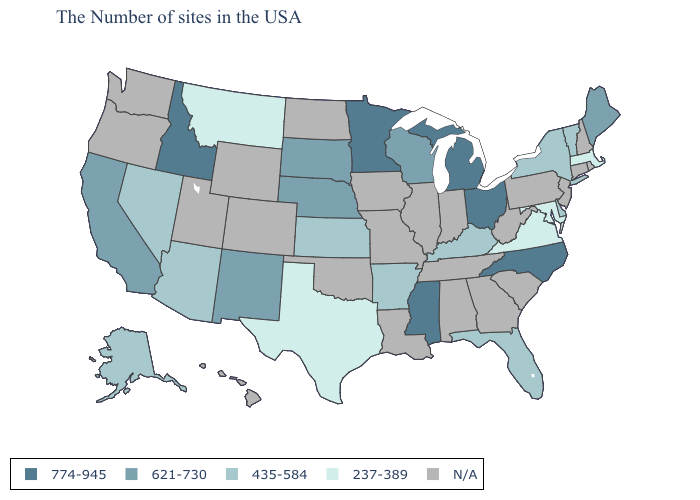What is the highest value in the USA?
Give a very brief answer. 774-945. What is the lowest value in the USA?
Be succinct. 237-389. What is the highest value in states that border Montana?
Short answer required. 774-945. What is the value of Wyoming?
Concise answer only. N/A. Name the states that have a value in the range 621-730?
Short answer required. Maine, Wisconsin, Nebraska, South Dakota, New Mexico, California. Does the map have missing data?
Keep it brief. Yes. Which states have the lowest value in the USA?
Short answer required. Massachusetts, Maryland, Virginia, Texas, Montana. What is the value of New York?
Be succinct. 435-584. What is the lowest value in the West?
Write a very short answer. 237-389. What is the highest value in the USA?
Answer briefly. 774-945. How many symbols are there in the legend?
Answer briefly. 5. What is the value of Alabama?
Short answer required. N/A. Name the states that have a value in the range N/A?
Keep it brief. Rhode Island, New Hampshire, Connecticut, New Jersey, Pennsylvania, South Carolina, West Virginia, Georgia, Indiana, Alabama, Tennessee, Illinois, Louisiana, Missouri, Iowa, Oklahoma, North Dakota, Wyoming, Colorado, Utah, Washington, Oregon, Hawaii. 